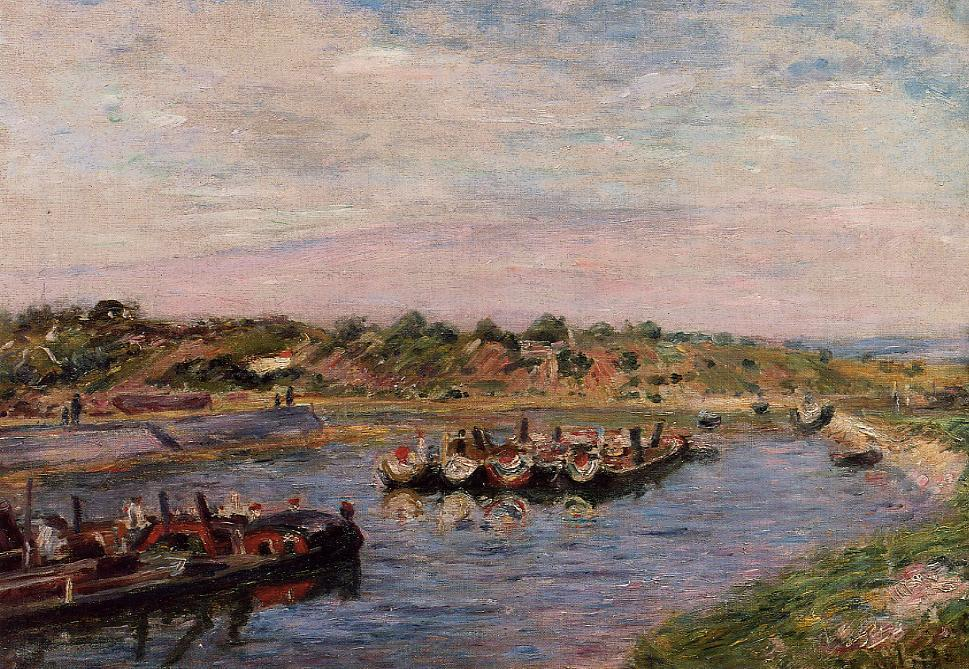If this painting were part of a story, what might the story be? In the story encapsulated by this painting, imagine a small riverside town named Bellevive, known for its annual Spring Festival. Every April, the townsfolk and visitors gather along the riverbanks to celebrate the arrival of spring with a grand parade of ornate boats. These boats, adorned with vibrant flags and banners, gracefully glide down the river, showcasing the artistic and cultural heritage of the town.

This particular scene captures the opening day of the festival. The townspeople, dressed in their finest attire, are filled with excitement and anticipation. The air is abuzz with the sounds of cheerful chatter, folk music, and the occasional laughter of children running around. Vendors set up colorful stalls offering local delicacies, hand-made crafts, and festive trinkets. 

We might follow the story through the eyes of a young girl named Clara. It's her first time attending the festival without parental supervision, and she’s eager to explore every corner of the celebration. As she meanders through the crowd, she encounters a variety of characters, each with their own stories and traditions tied to the festival. She meets an old boatman who shares tales of river legends, a local artist capturing the scene on canvas, and a group of dancers preparing for their performance. 

The story weaves through these interactions, highlighting the generational bonds and the town’s close-knit community spirit, ultimately culminating in a spectacular fireworks display over the river, symbolizing the town’s unity and the enduring charm of the Bellevive Spring Festival. What might be the mood and atmosphere if this scene was set during a storm? If the sharegpt4v/same scene were set during a storm, the mood and atmosphere would dramatically shift from one of tranquility to one of tension and drama. The sky would be dark and foreboding, with heavy clouds casting shadows over the landscape. Turbulent waves would replace the serene river, with boats rocking violently or desperately seeking shelter.

People along the riverbanks would be seen scrambling for cover, their colorful clothes now drenched and clinging to them as they shield themselves from the pounding rain. Umbrellas might be turned inside out by the gusting winds, and hats could be seen flying off into the distance. The once festive and leisurely atmosphere would now be charged with urgency and a sense of survival.

In the background, the hills might appear darker and more ominous, with trees bending under the force of the wind. Houses would have their lights on, casting a dim glow through the heavy downpour, adding to the dramatic effect. The contrast between the cozy indoors and the stormy outdoors would be stark and palpable.

The overall feeling would be one of raw nature overpowering the man-made festivities, a reminder of the uncontrollable might of the elements and their ability to change human plans in an instant. How would this scene look on an alien planet? Imagine this scene on an alien planet called Vortexa in the Andromeda galaxy. Instead of a river with blue water, you might see a wide canal filled with a shimmering, iridescent liquid that changes color based on the angle of the light. The boats here are not typical wooden or motorized vessels, but sleek, levitating crafts that hover above the liquid surface.

The riverbanks are dotted with bioluminescent flora, casting an otherworldly glow in hues of violet and cyan. The people, if they can be called that, are tall, slender beings with translucent skin and multifaceted eyes that reflect the ever-changing colors of the canal. They communicate through a series of melodic tones that resonate through the air, creating a harmonious background against the vibrant festival.

In the sky, two moons hang close together, creating an ethereal twilight ambiance. Strange, floating orbs of light drift gently through the upper atmosphere, occasionally descending to interact with the beings below, adding a touch of celestial magic to the scene. The architecture in the background consists of crystalline structures that catch and refract the light, creating a dazzling spectacle.

The festival here on Vortexa is a celebration of the planet’s bi-annual alignment with its moons, an event that leads to an increase in the canal's iridescent glow. The whole scene is a fusion of futuristic technology and alien natural beauty, painting a picture of a festival that is both awe-inspiring and deeply harmonious with the unique environment of Vortexa. 